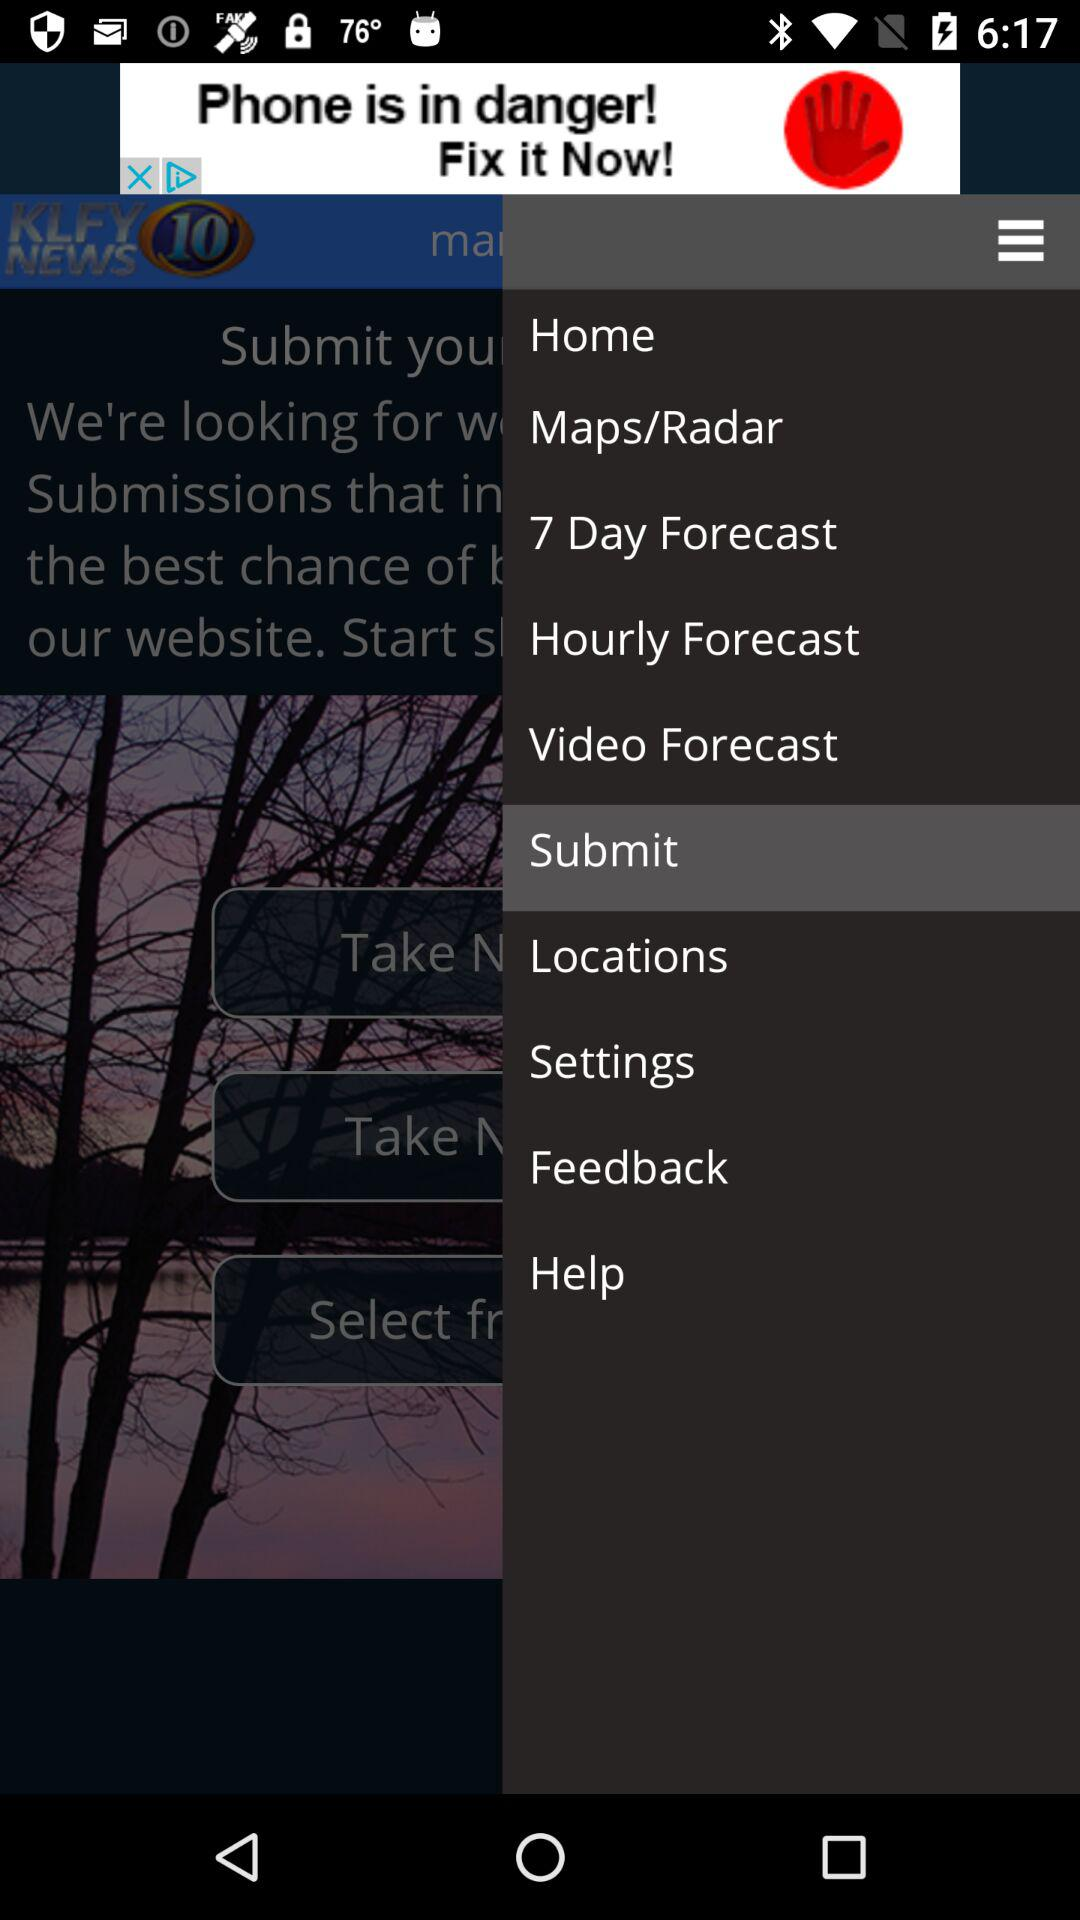What is the name of the application? The name of the application is "KLFY News 10". 